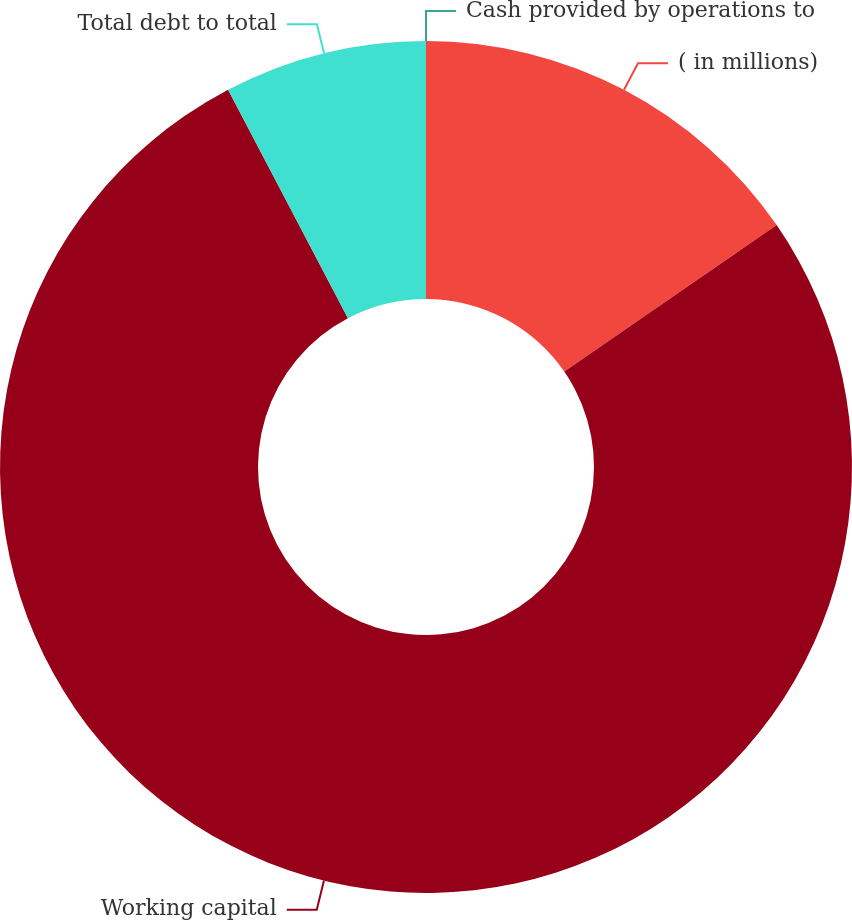Convert chart. <chart><loc_0><loc_0><loc_500><loc_500><pie_chart><fcel>( in millions)<fcel>Working capital<fcel>Total debt to total<fcel>Cash provided by operations to<nl><fcel>15.39%<fcel>76.92%<fcel>7.69%<fcel>0.0%<nl></chart> 